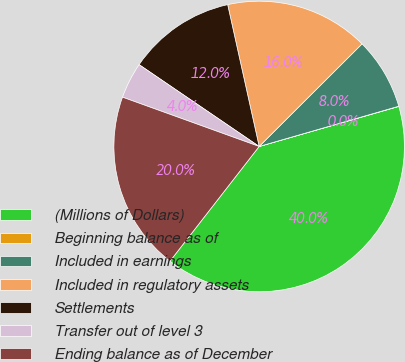<chart> <loc_0><loc_0><loc_500><loc_500><pie_chart><fcel>(Millions of Dollars)<fcel>Beginning balance as of<fcel>Included in earnings<fcel>Included in regulatory assets<fcel>Settlements<fcel>Transfer out of level 3<fcel>Ending balance as of December<nl><fcel>39.96%<fcel>0.02%<fcel>8.01%<fcel>16.0%<fcel>12.0%<fcel>4.01%<fcel>19.99%<nl></chart> 